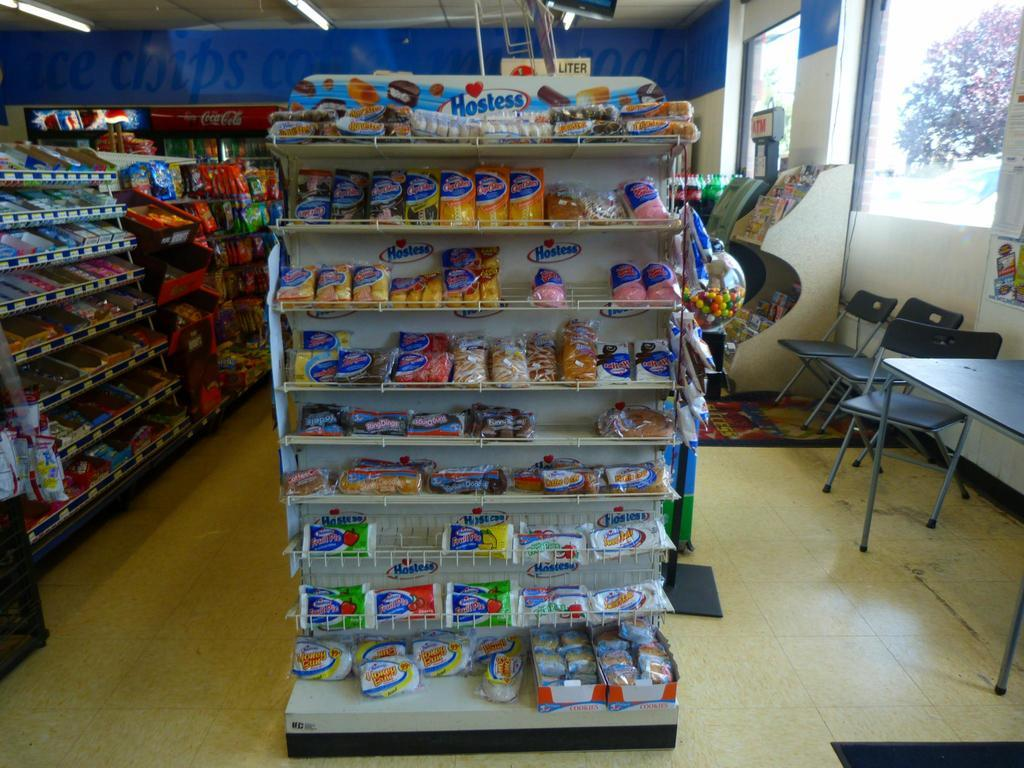<image>
Present a compact description of the photo's key features. a Hostess stand sits in a store with many items 